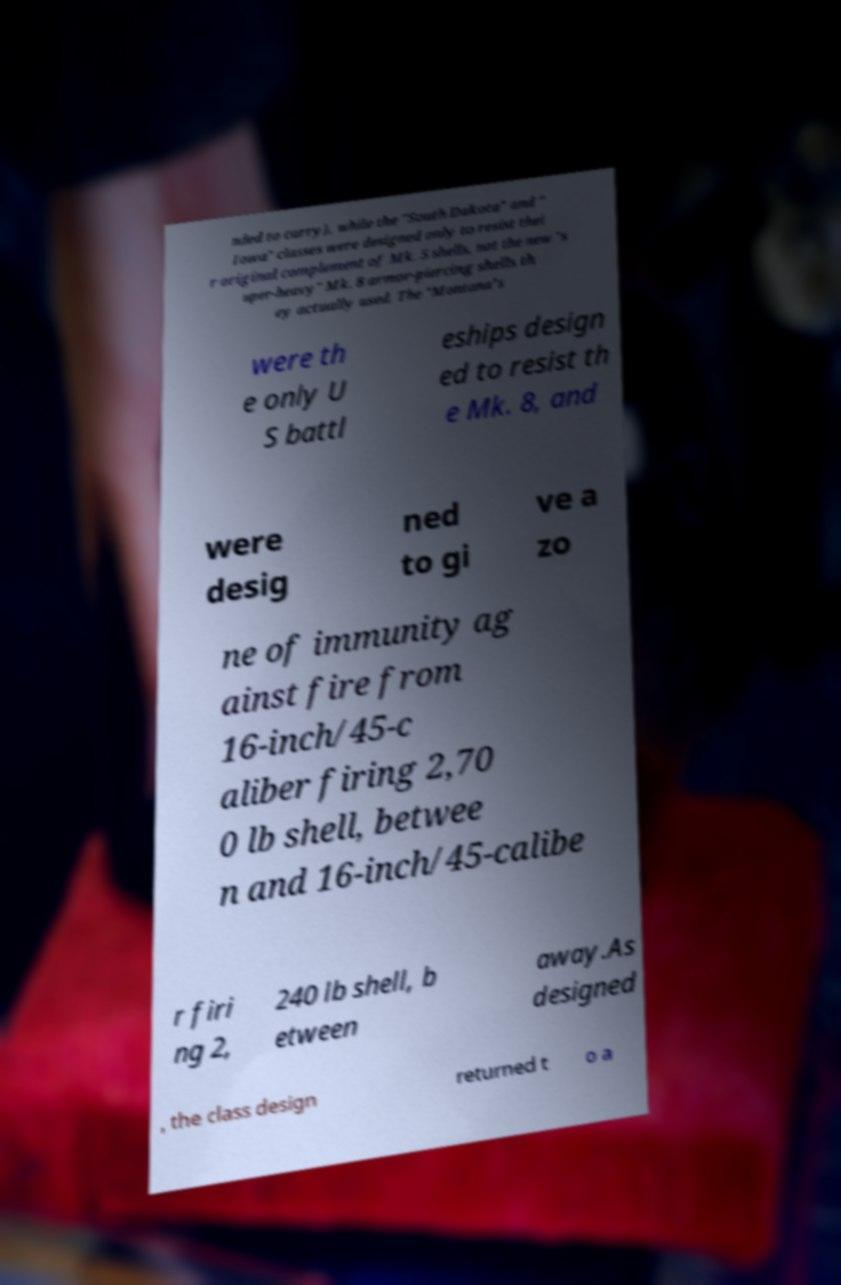For documentation purposes, I need the text within this image transcribed. Could you provide that? nded to carry), while the "South Dakota" and " Iowa" classes were designed only to resist thei r original complement of Mk. 5 shells, not the new "s uper-heavy" Mk. 8 armor-piercing shells th ey actually used. The "Montana"s were th e only U S battl eships design ed to resist th e Mk. 8, and were desig ned to gi ve a zo ne of immunity ag ainst fire from 16-inch/45-c aliber firing 2,70 0 lb shell, betwee n and 16-inch/45-calibe r firi ng 2, 240 lb shell, b etween away.As designed , the class design returned t o a 